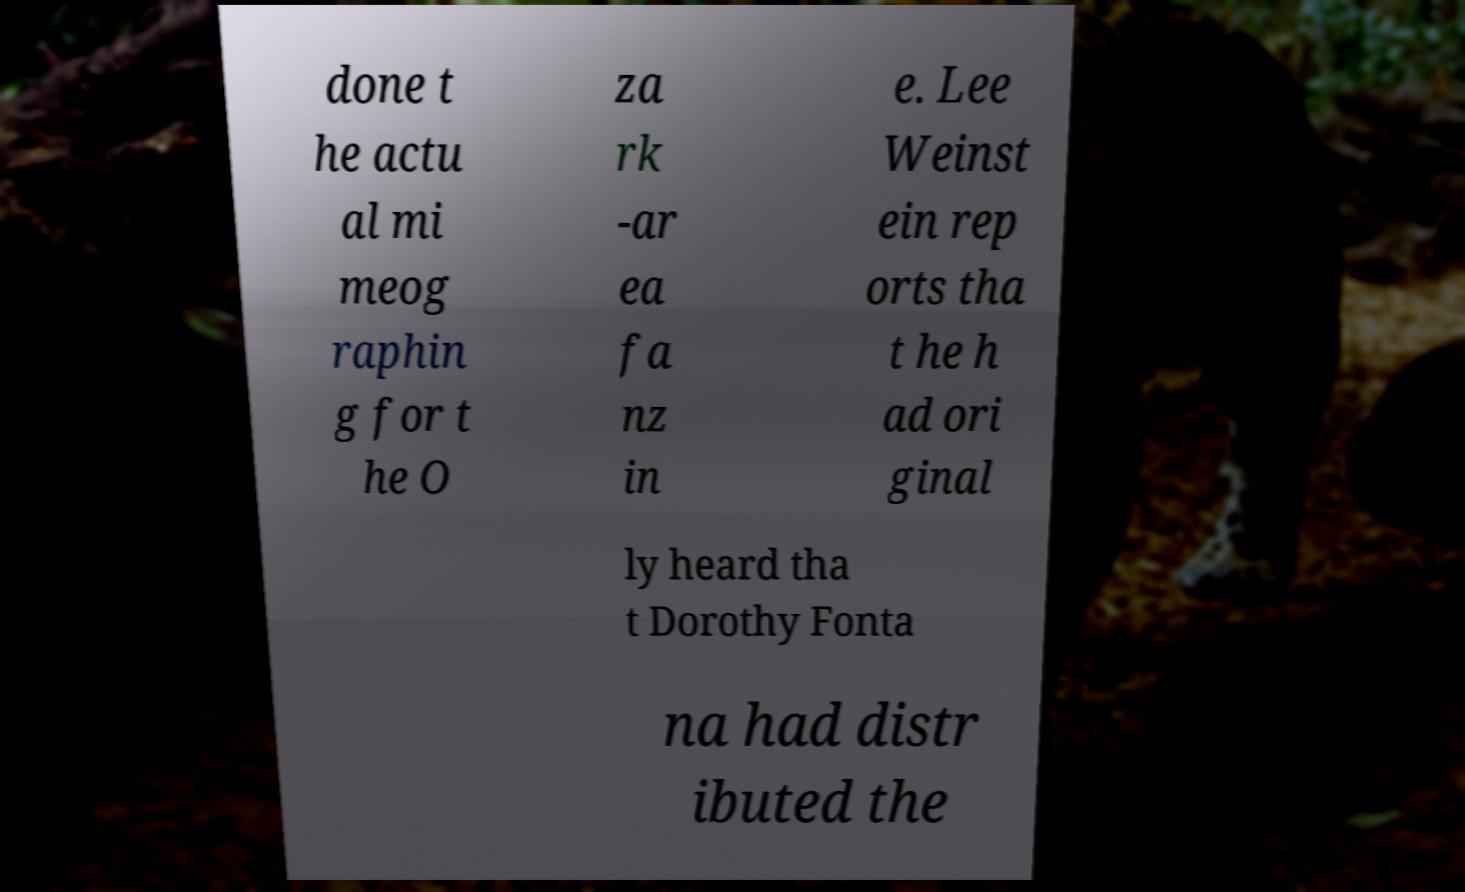I need the written content from this picture converted into text. Can you do that? done t he actu al mi meog raphin g for t he O za rk -ar ea fa nz in e. Lee Weinst ein rep orts tha t he h ad ori ginal ly heard tha t Dorothy Fonta na had distr ibuted the 